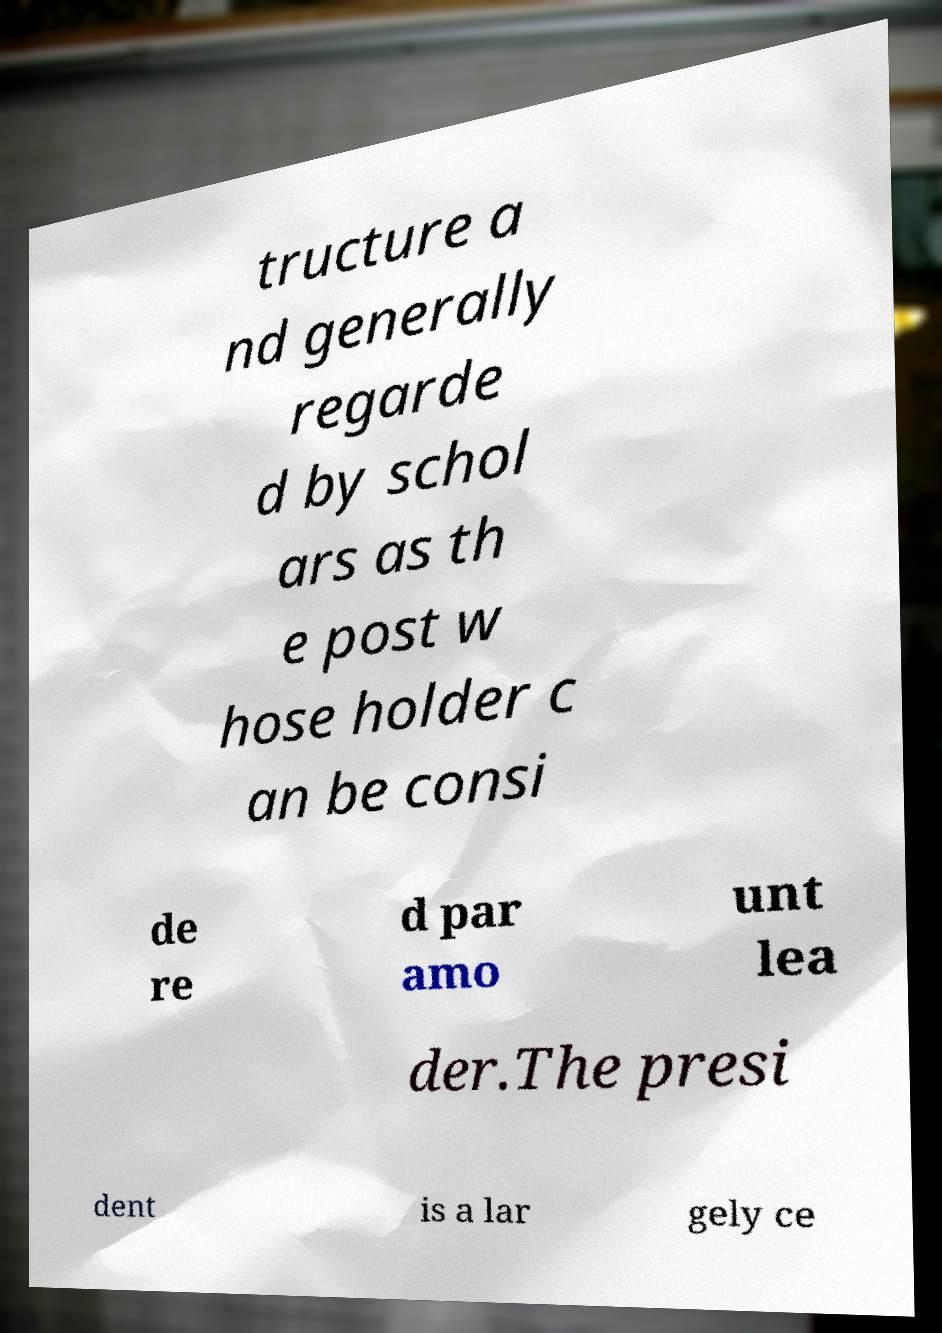Please read and relay the text visible in this image. What does it say? tructure a nd generally regarde d by schol ars as th e post w hose holder c an be consi de re d par amo unt lea der.The presi dent is a lar gely ce 